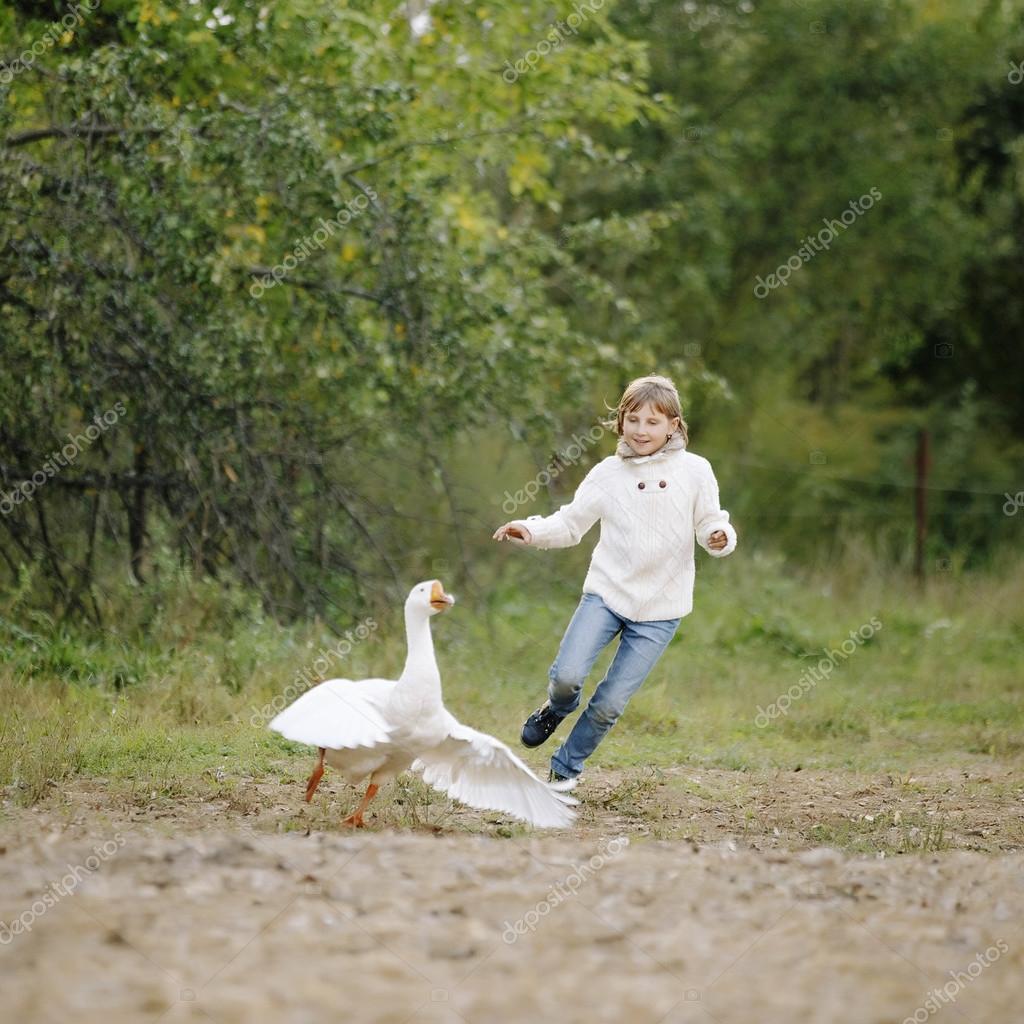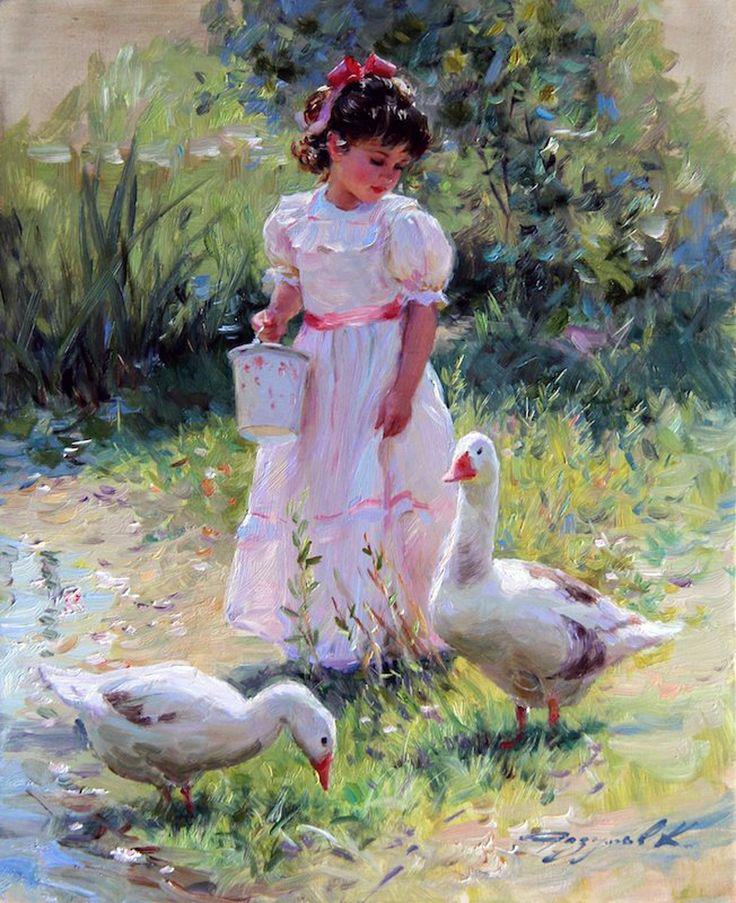The first image is the image on the left, the second image is the image on the right. Analyze the images presented: Is the assertion "The left image shows a child running near a white goose with wings spread, and the right image shows a girl in a dress holding something and standing by multiple geese." valid? Answer yes or no. Yes. The first image is the image on the left, the second image is the image on the right. Evaluate the accuracy of this statement regarding the images: "This a goose white white belly trying to bite a small scared child.". Is it true? Answer yes or no. No. 